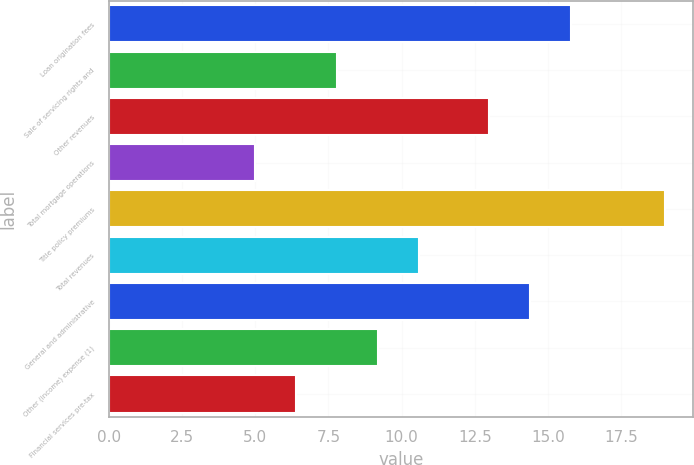Convert chart. <chart><loc_0><loc_0><loc_500><loc_500><bar_chart><fcel>Loan origination fees<fcel>Sale of servicing rights and<fcel>Other revenues<fcel>Total mortgage operations<fcel>Title policy premiums<fcel>Total revenues<fcel>General and administrative<fcel>Other (income) expense (1)<fcel>Financial services pre-tax<nl><fcel>15.8<fcel>7.8<fcel>13<fcel>5<fcel>19<fcel>10.6<fcel>14.4<fcel>9.2<fcel>6.4<nl></chart> 